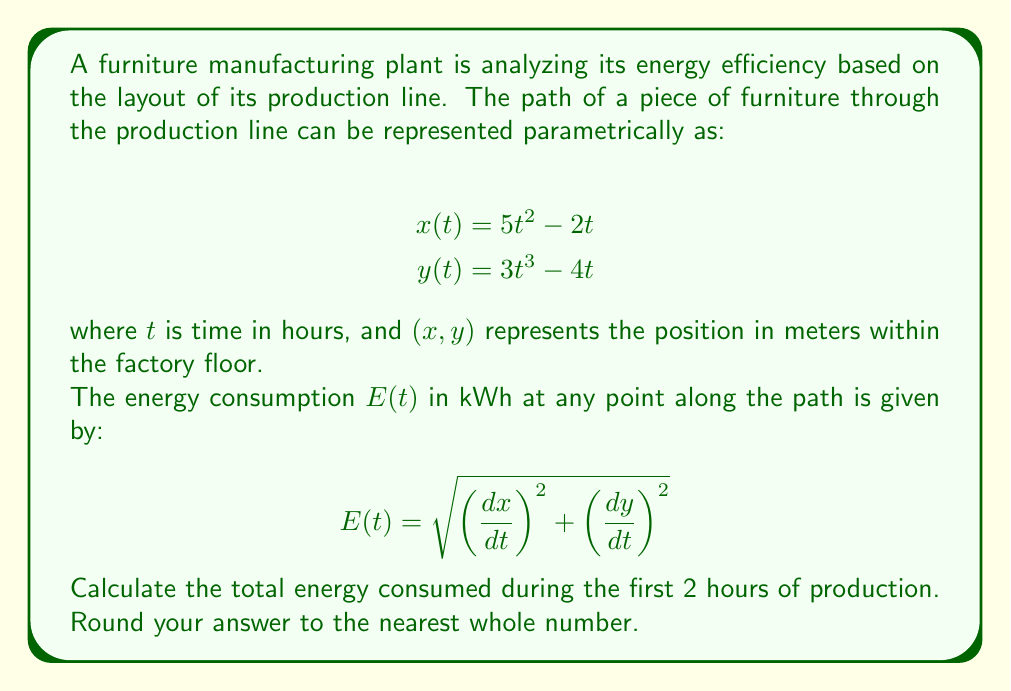What is the answer to this math problem? To solve this problem, we need to follow these steps:

1) First, we need to find the derivatives $\frac{dx}{dt}$ and $\frac{dy}{dt}$:

   $$\frac{dx}{dt} = 10t - 2$$
   $$\frac{dy}{dt} = 9t^2 - 4$$

2) Now we can substitute these into the energy consumption formula:

   $$E(t) = \sqrt{(10t - 2)^2 + (9t^2 - 4)^2}$$

3) To find the total energy consumed over the first 2 hours, we need to integrate this function from $t=0$ to $t=2$:

   $$\text{Total Energy} = \int_0^2 \sqrt{(10t - 2)^2 + (9t^2 - 4)^2} \, dt$$

4) This integral is complex and doesn't have a simple analytical solution. We need to use numerical integration methods. One common method is the trapezoidal rule:

   $$\int_a^b f(x) \, dx \approx \frac{b-a}{2n}\sum_{k=1}^n [f(x_{k-1}) + f(x_k)]$$

   where $n$ is the number of subintervals and $x_k = a + k\frac{b-a}{n}$.

5) Let's use $n=1000$ for a good approximation:

   $$\text{Total Energy} \approx \frac{2-0}{2(1000)}\sum_{k=1}^{1000} [E(t_{k-1}) + E(t_k)]$$

   where $t_k = 0 + k\frac{2-0}{1000} = \frac{k}{500}$

6) Calculating this sum numerically (which would typically be done with a computer or calculator) gives us approximately 70.71 kWh.

7) Rounding to the nearest whole number gives us 71 kWh.
Answer: 71 kWh 